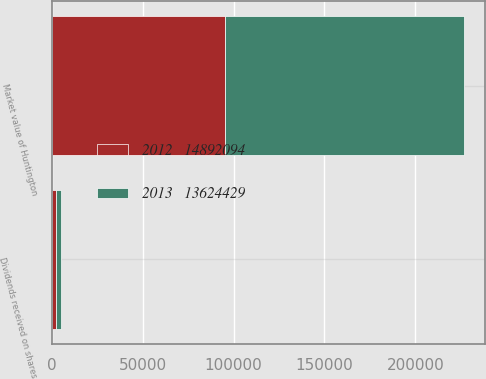Convert chart. <chart><loc_0><loc_0><loc_500><loc_500><stacked_bar_chart><ecel><fcel>Market value of Huntington<fcel>Dividends received on shares<nl><fcel>2013   13624429<fcel>131476<fcel>2567<nl><fcel>2012   14892094<fcel>95160<fcel>2414<nl></chart> 